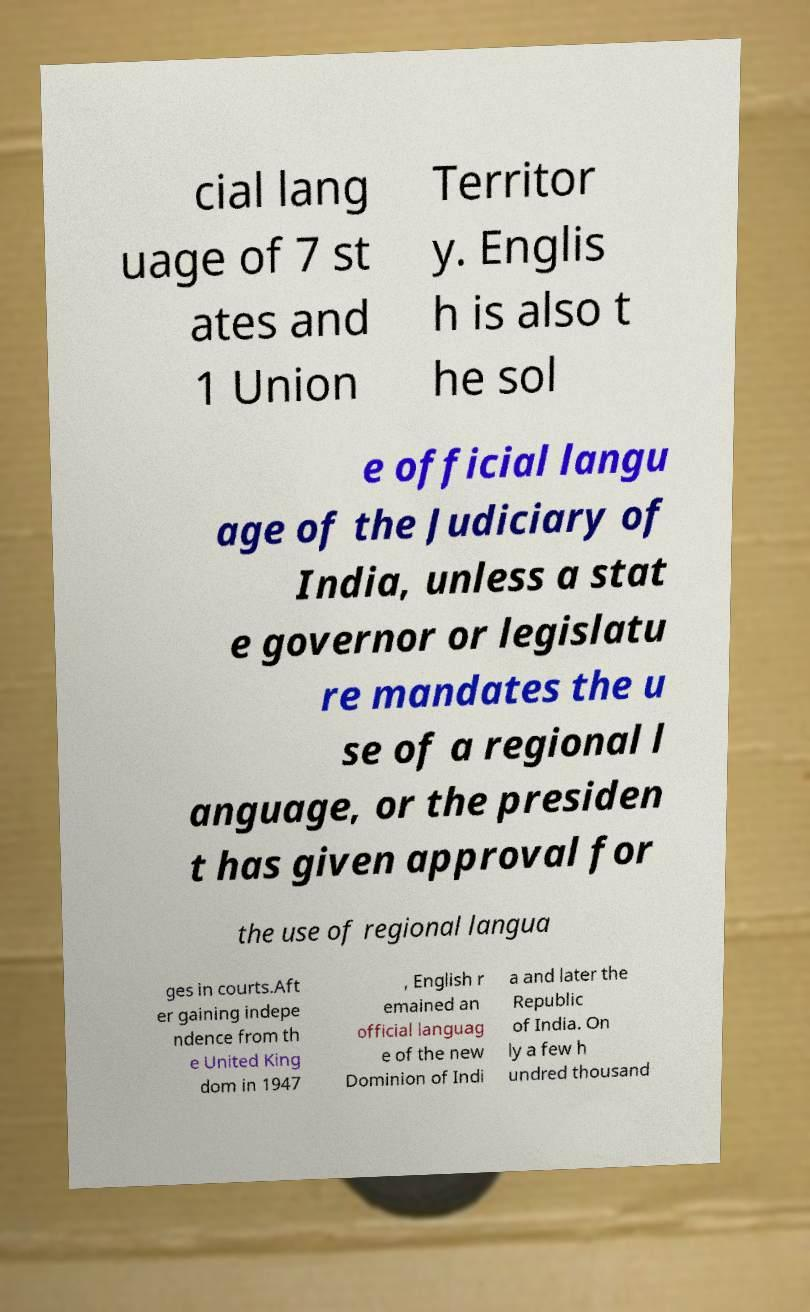Could you extract and type out the text from this image? cial lang uage of 7 st ates and 1 Union Territor y. Englis h is also t he sol e official langu age of the Judiciary of India, unless a stat e governor or legislatu re mandates the u se of a regional l anguage, or the presiden t has given approval for the use of regional langua ges in courts.Aft er gaining indepe ndence from th e United King dom in 1947 , English r emained an official languag e of the new Dominion of Indi a and later the Republic of India. On ly a few h undred thousand 